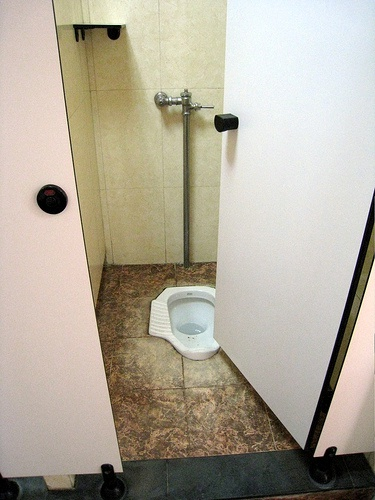Describe the objects in this image and their specific colors. I can see a toilet in darkgray and lightgray tones in this image. 